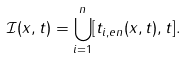<formula> <loc_0><loc_0><loc_500><loc_500>\mathcal { I } ( x , t ) = \bigcup _ { i = 1 } ^ { n } [ t _ { i , e n } ( x , t ) , t ] .</formula> 